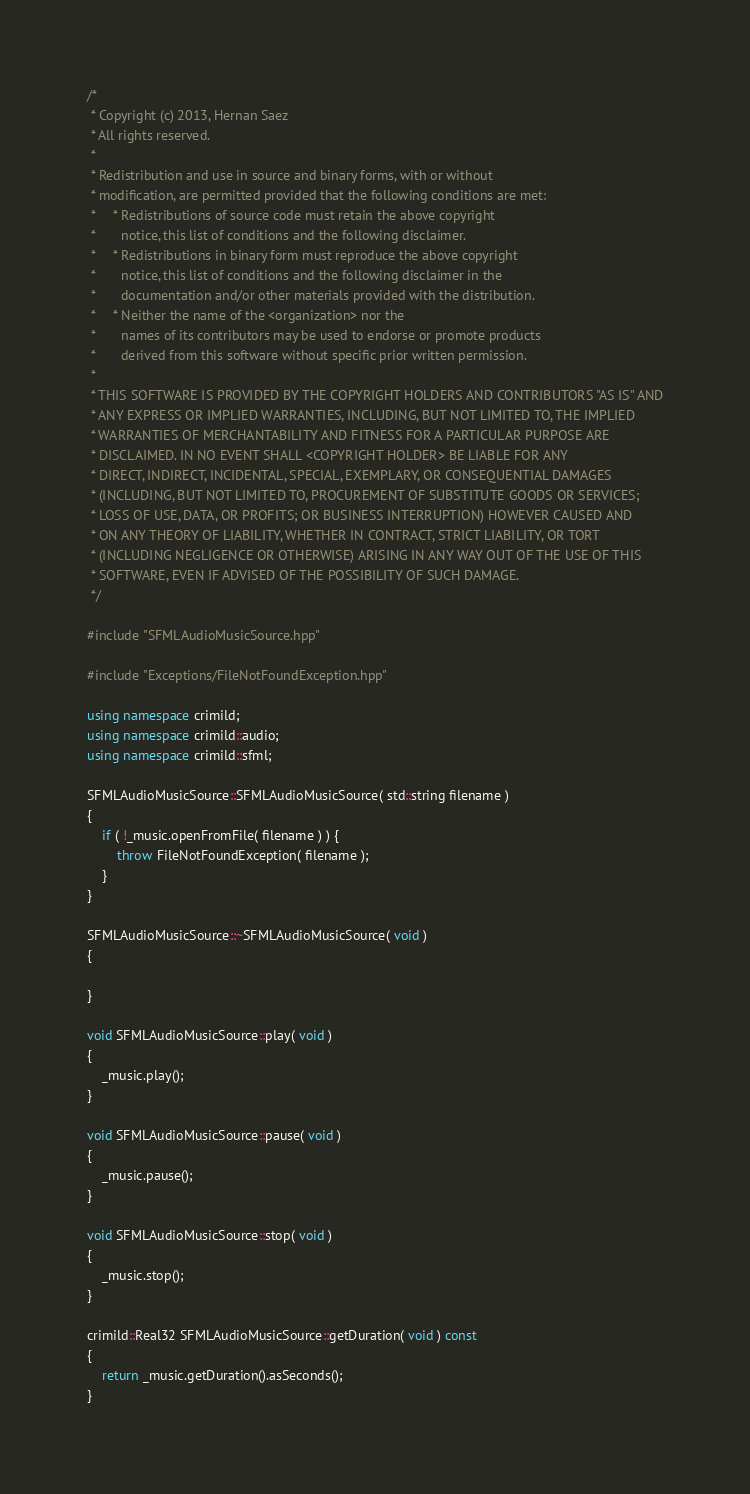Convert code to text. <code><loc_0><loc_0><loc_500><loc_500><_C++_>/*
 * Copyright (c) 2013, Hernan Saez
 * All rights reserved.
 * 
 * Redistribution and use in source and binary forms, with or without
 * modification, are permitted provided that the following conditions are met:
 *     * Redistributions of source code must retain the above copyright
 *       notice, this list of conditions and the following disclaimer.
 *     * Redistributions in binary form must reproduce the above copyright
 *       notice, this list of conditions and the following disclaimer in the
 *       documentation and/or other materials provided with the distribution.
 *     * Neither the name of the <organization> nor the
 *       names of its contributors may be used to endorse or promote products
 *       derived from this software without specific prior written permission.
 * 
 * THIS SOFTWARE IS PROVIDED BY THE COPYRIGHT HOLDERS AND CONTRIBUTORS "AS IS" AND
 * ANY EXPRESS OR IMPLIED WARRANTIES, INCLUDING, BUT NOT LIMITED TO, THE IMPLIED
 * WARRANTIES OF MERCHANTABILITY AND FITNESS FOR A PARTICULAR PURPOSE ARE
 * DISCLAIMED. IN NO EVENT SHALL <COPYRIGHT HOLDER> BE LIABLE FOR ANY
 * DIRECT, INDIRECT, INCIDENTAL, SPECIAL, EXEMPLARY, OR CONSEQUENTIAL DAMAGES
 * (INCLUDING, BUT NOT LIMITED TO, PROCUREMENT OF SUBSTITUTE GOODS OR SERVICES;
 * LOSS OF USE, DATA, OR PROFITS; OR BUSINESS INTERRUPTION) HOWEVER CAUSED AND
 * ON ANY THEORY OF LIABILITY, WHETHER IN CONTRACT, STRICT LIABILITY, OR TORT
 * (INCLUDING NEGLIGENCE OR OTHERWISE) ARISING IN ANY WAY OUT OF THE USE OF THIS
 * SOFTWARE, EVEN IF ADVISED OF THE POSSIBILITY OF SUCH DAMAGE.
 */

#include "SFMLAudioMusicSource.hpp"

#include "Exceptions/FileNotFoundException.hpp"

using namespace crimild;
using namespace crimild::audio;
using namespace crimild::sfml;

SFMLAudioMusicSource::SFMLAudioMusicSource( std::string filename )
{
    if ( !_music.openFromFile( filename ) ) {
		throw FileNotFoundException( filename );
	}
}

SFMLAudioMusicSource::~SFMLAudioMusicSource( void )
{

}

void SFMLAudioMusicSource::play( void )
{
	_music.play();
}

void SFMLAudioMusicSource::pause( void )
{
	_music.pause();
}

void SFMLAudioMusicSource::stop( void )
{
	_music.stop();
}

crimild::Real32 SFMLAudioMusicSource::getDuration( void ) const
{
	return _music.getDuration().asSeconds();
}
</code> 